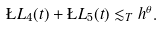<formula> <loc_0><loc_0><loc_500><loc_500>\L L _ { 4 } ( t ) + \L L _ { 5 } ( t ) \lesssim _ { T } h ^ { \theta } .</formula> 